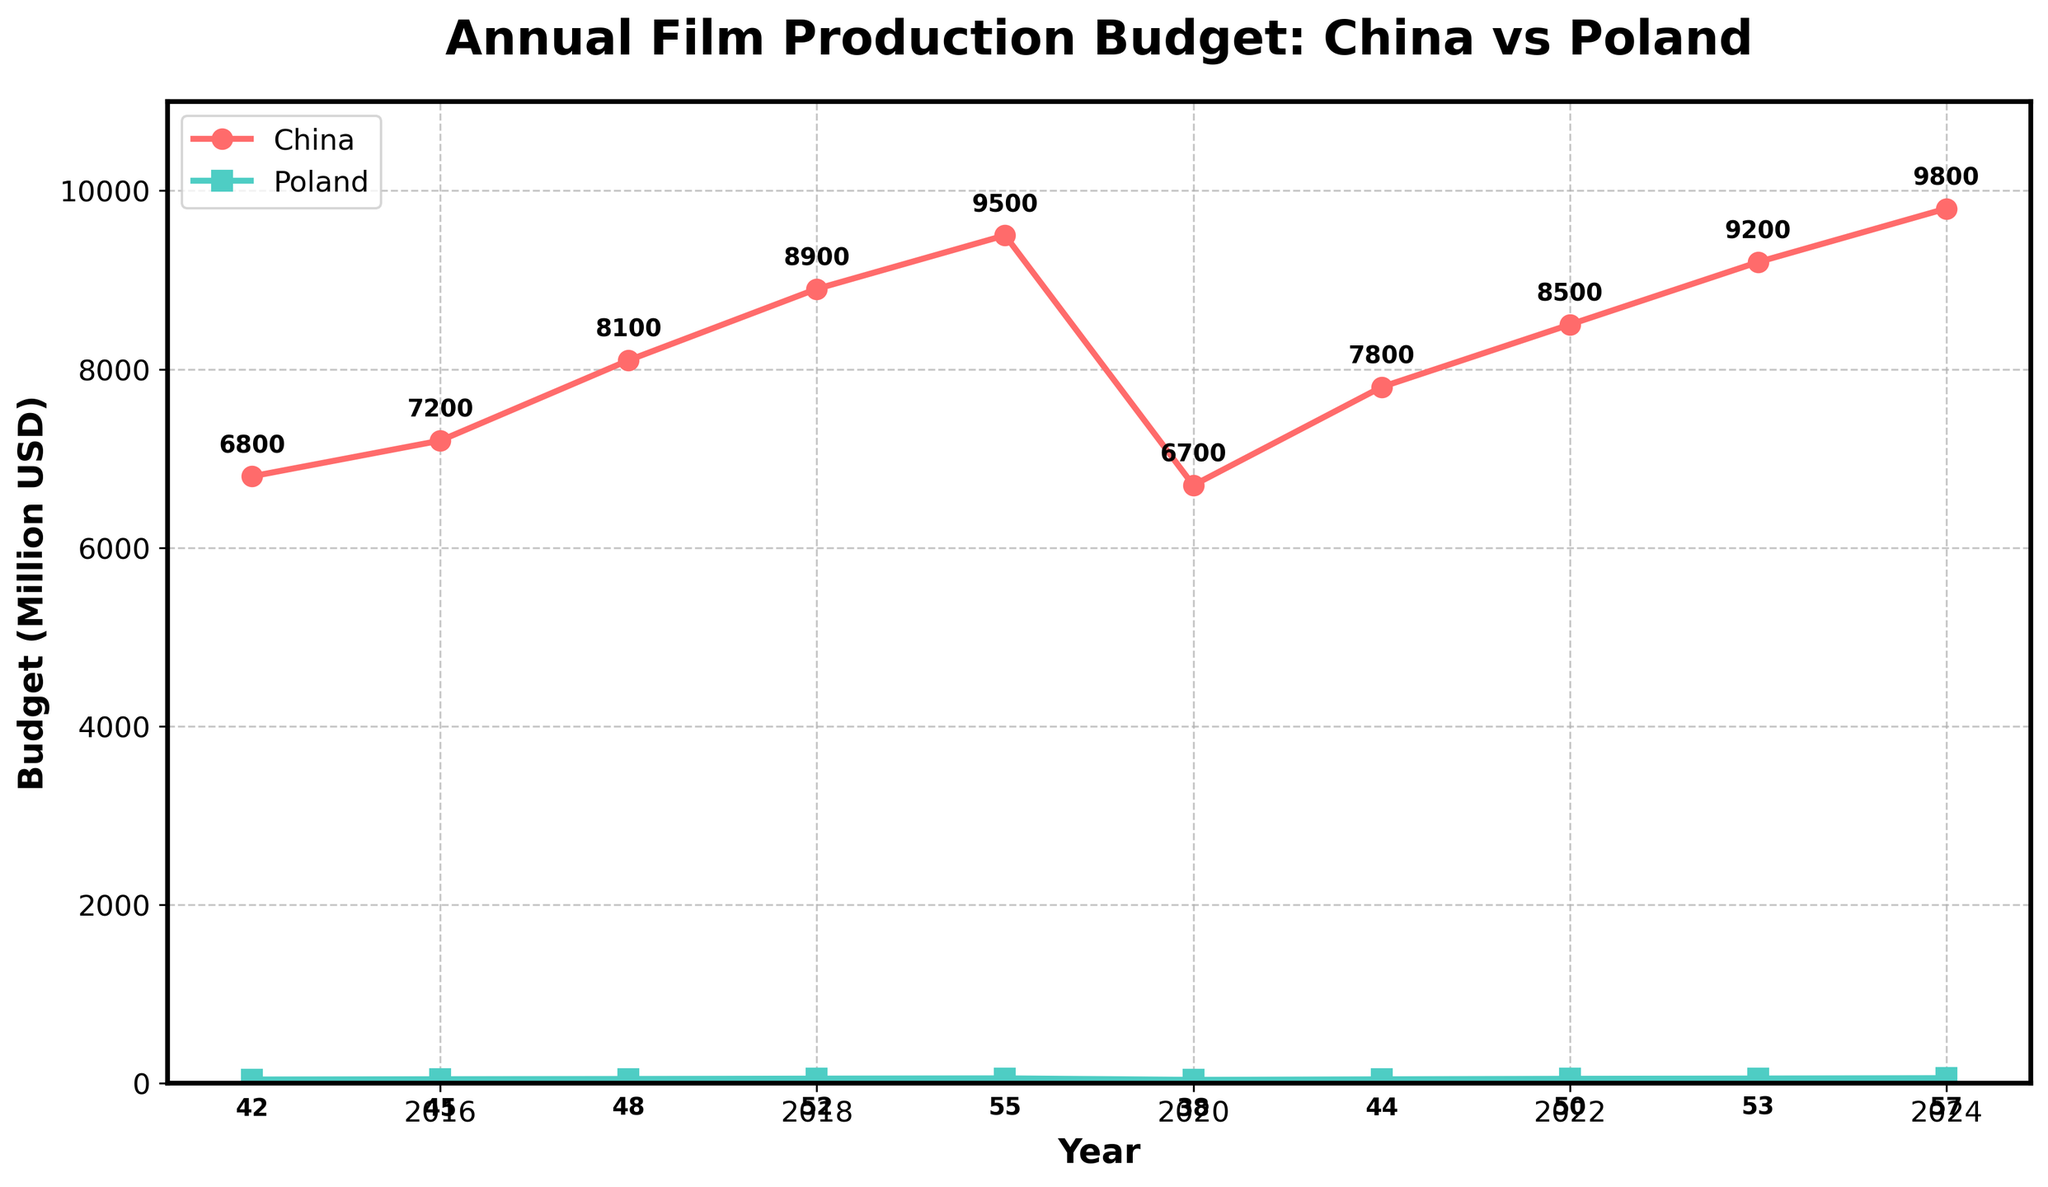Which country had the highest film production budget in 2023? By looking at the data points for the year 2023 on the plot, we can observe which line is higher. The line representing China remains above the line representing Poland. Thus, China's film production budget is higher.
Answer: China What was the difference between the film production budgets of China and Poland in 2015? To find the difference, we subtract Poland's budget in 2015 from China's budget in 2015. China's budget was 6800 million USD while Poland's was 42 million USD. So, 6800 - 42 = 6758 million USD.
Answer: 6758 million USD In which year did Poland's film production budget first reach or exceed 50 million USD? We need to find the first year where the Poland line reaches or exceeds the 50 million USD mark. By looking at the data points on the plot, Poland's budget first reaches 50 million USD in 2022.
Answer: 2022 What is the total film production budget for China from 2016 to 2018? We sum up the annual budgets of China for the years 2016, 2017, and 2018. This is 7200 + 8100 + 8900 = 24200 million USD.
Answer: 24200 million USD Which year saw the largest decrease in China's film production budget compared to the previous year? By examining the drops from year to year in the plot for China's budget, the largest decrease is between 2019 and 2020, where the budget fell from 9500 million USD to 6700 million USD, a drop of 2800 million USD.
Answer: 2020 In which year did both China and Poland have their film production budgets aligned in terms of increasing or decreasing? We need to identify a year where both China's and Poland's budgets either increased or decreased from the previous year. This can be seen in 2021, where both countries had an increase in their budgets compared to 2020.
Answer: 2021 By how much did Poland's film production budget increase from 2019 to 2024? To find this, we subtract Poland's 2019 budget from the 2024 budget. So, 57 - 55 = 2 million USD.
Answer: 2 million USD What was the average film production budget for Poland from 2015 to 2024? We find the average by summing Poland's budgets from 2015 to 2024 and dividing by the number of years. Summing the budgets gives 42 + 45 + 48 + 52 + 55 + 38 + 44 + 50 + 53 + 57 = 484 million USD. Dividing by 10 years, the average is 484 / 10 = 48.4 million USD.
Answer: 48.4 million USD Which country had a higher annual film production budget growth rate from 2015 to 2024? To compare growth rates, we look at the slope of the lines representing each country's budget over the years. China's budget grows from 6800 to 9800 million USD, and Poland's from 42 to 57 million USD between 2015 and 2024. China's growth is 9800 - 6800 = 3000 million USD over 9 years, while Poland’s growth is 57 - 42 = 15 million USD over the same period. China's higher absolute growth rate suggests a higher annual growth rate.
Answer: China What is the combined total film production budget of China and Poland in 2024? Adding China’s budget and Poland’s budget for the year 2024 provides the total budget. This is 9800 + 57 = 9857 million USD.
Answer: 9857 million USD 